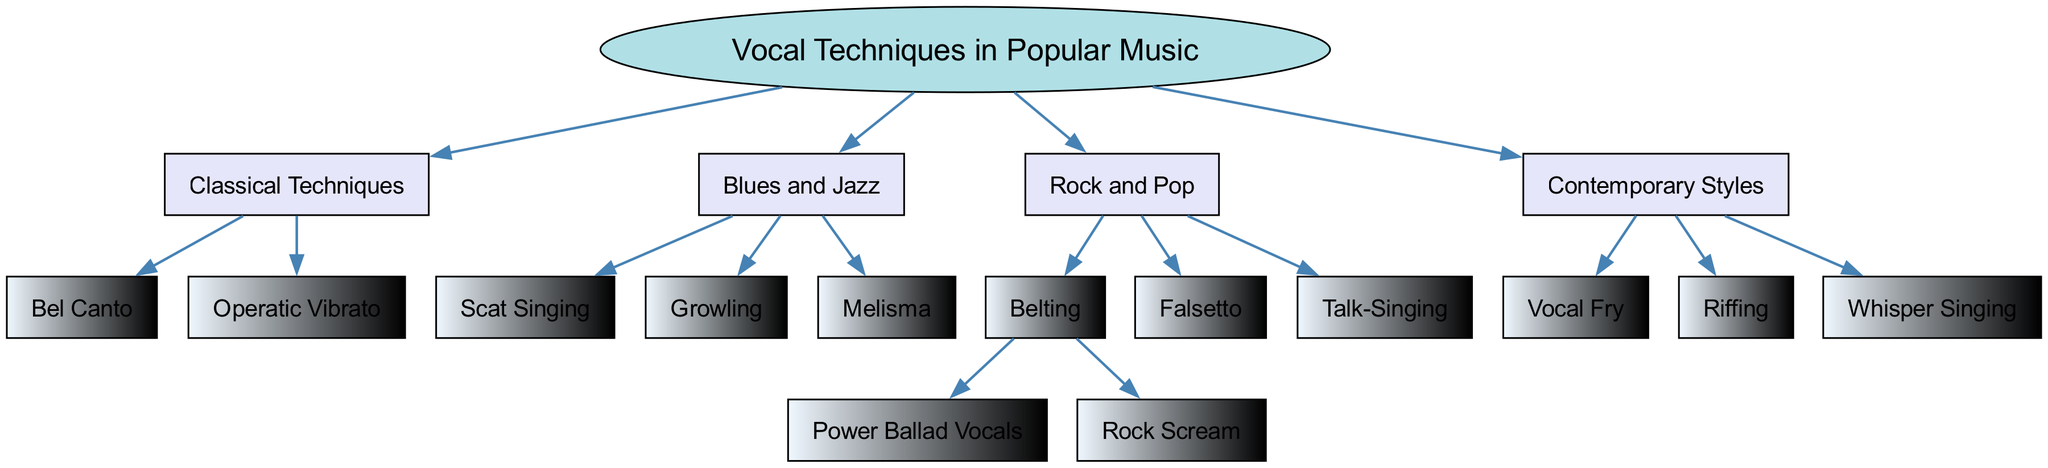What is the root of the family tree? The root node of the diagram explicitly states "Vocal Techniques in Popular Music," which serves as the foundation for all subsequent branches.
Answer: Vocal Techniques in Popular Music How many main branches are there? The branches stemming from the root are listed as Classical Techniques, Blues and Jazz, Rock and Pop, and Contemporary Styles. Counting these gives four main branches.
Answer: 4 Which technique falls under the Blues and Jazz branch? The available techniques listed under the Blues and Jazz branch include Scat Singing, Growling, and Melisma. Melisma is one of the options and can directly be identified under this branch.
Answer: Melisma What vocal technique is a child of Rock and Pop? Within the Rock and Pop branch, techniques such as Belting, Falsetto, and Talk-Singing are found. Identifying these shows that both Belting and others fit the criteria of being children of this main branch.
Answer: Belting How many children does the Belting technique have? The Belting technique is specifically noted to have two children: Power Ballad Vocals and Rock Scream. Therefore, by counting these techniques under Belting, we can determine the number.
Answer: 2 Which classical technique is known for its beautiful singing? Among the techniques listed in the Classical Techniques branch, Bel Canto is recognized for its emphasis on beautiful singing style and expressive phrasing, distinguishing it from Operatic Vibrato.
Answer: Bel Canto What style is characterized by whisper singing? In the Contemporary Styles branch, Whisper Singing represents a unique vocal approach that is specifically noted here among other modern techniques such as Vocal Fry and Riffing.
Answer: Whisper Singing How many vocal techniques are there in Contemporary Styles? The techniques specified under Contemporary Styles are Vocal Fry, Riffing, and Whisper Singing, which sums up to three distinct vocal techniques.
Answer: 3 What is the relationship between operatic vibrato and Classical Techniques? Operatic Vibrato is a technique that falls directly under the Classical Techniques branch, illustrating a clear hierarchical relationship where it is a child of that specific branch.
Answer: Operatic Vibrato 